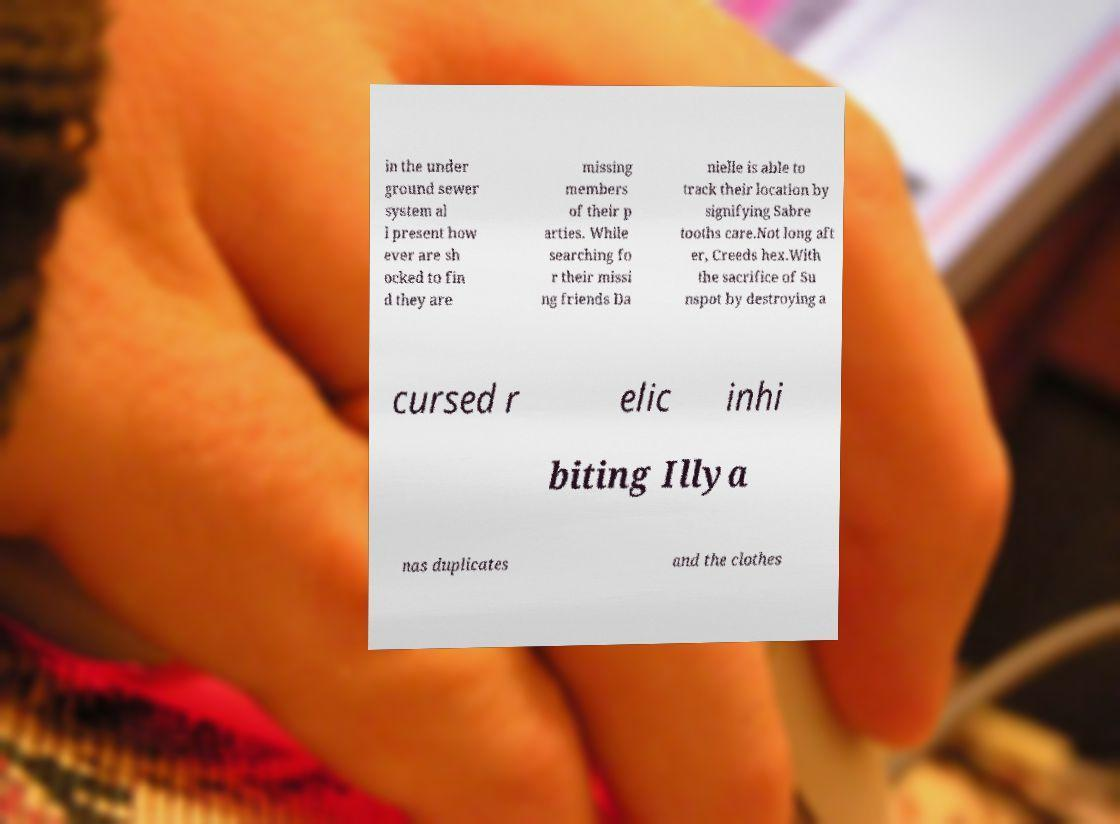Can you accurately transcribe the text from the provided image for me? in the under ground sewer system al l present how ever are sh ocked to fin d they are missing members of their p arties. While searching fo r their missi ng friends Da nielle is able to track their location by signifying Sabre tooths care.Not long aft er, Creeds hex.With the sacrifice of Su nspot by destroying a cursed r elic inhi biting Illya nas duplicates and the clothes 